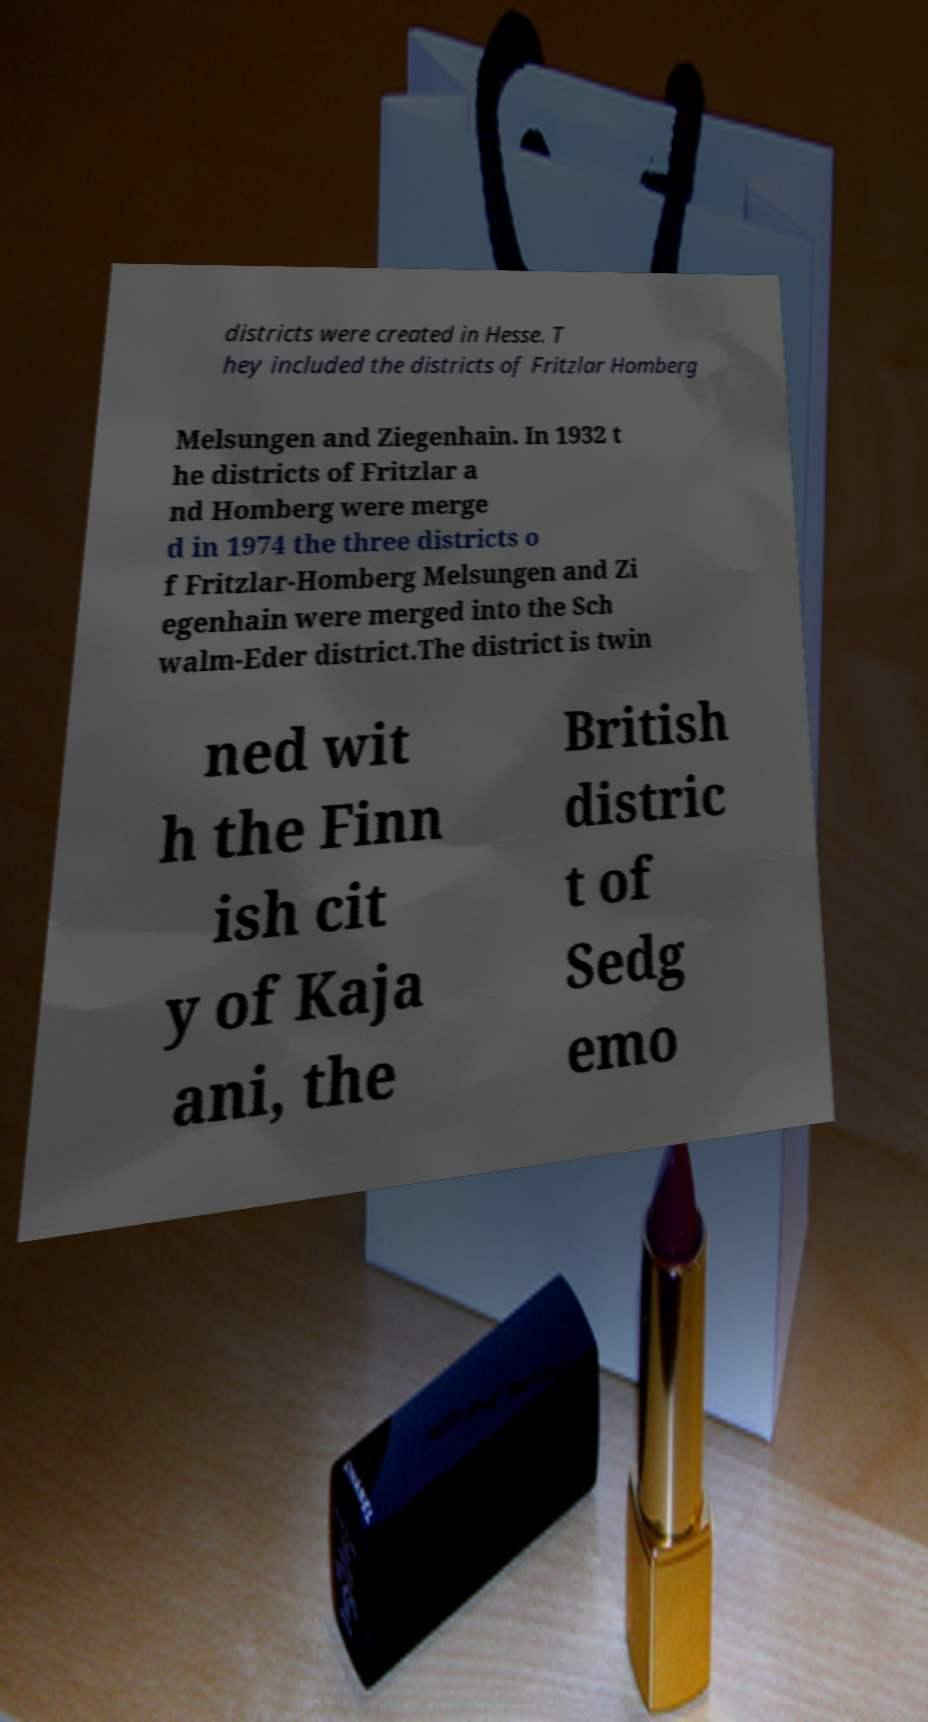Can you read and provide the text displayed in the image?This photo seems to have some interesting text. Can you extract and type it out for me? districts were created in Hesse. T hey included the districts of Fritzlar Homberg Melsungen and Ziegenhain. In 1932 t he districts of Fritzlar a nd Homberg were merge d in 1974 the three districts o f Fritzlar-Homberg Melsungen and Zi egenhain were merged into the Sch walm-Eder district.The district is twin ned wit h the Finn ish cit y of Kaja ani, the British distric t of Sedg emo 